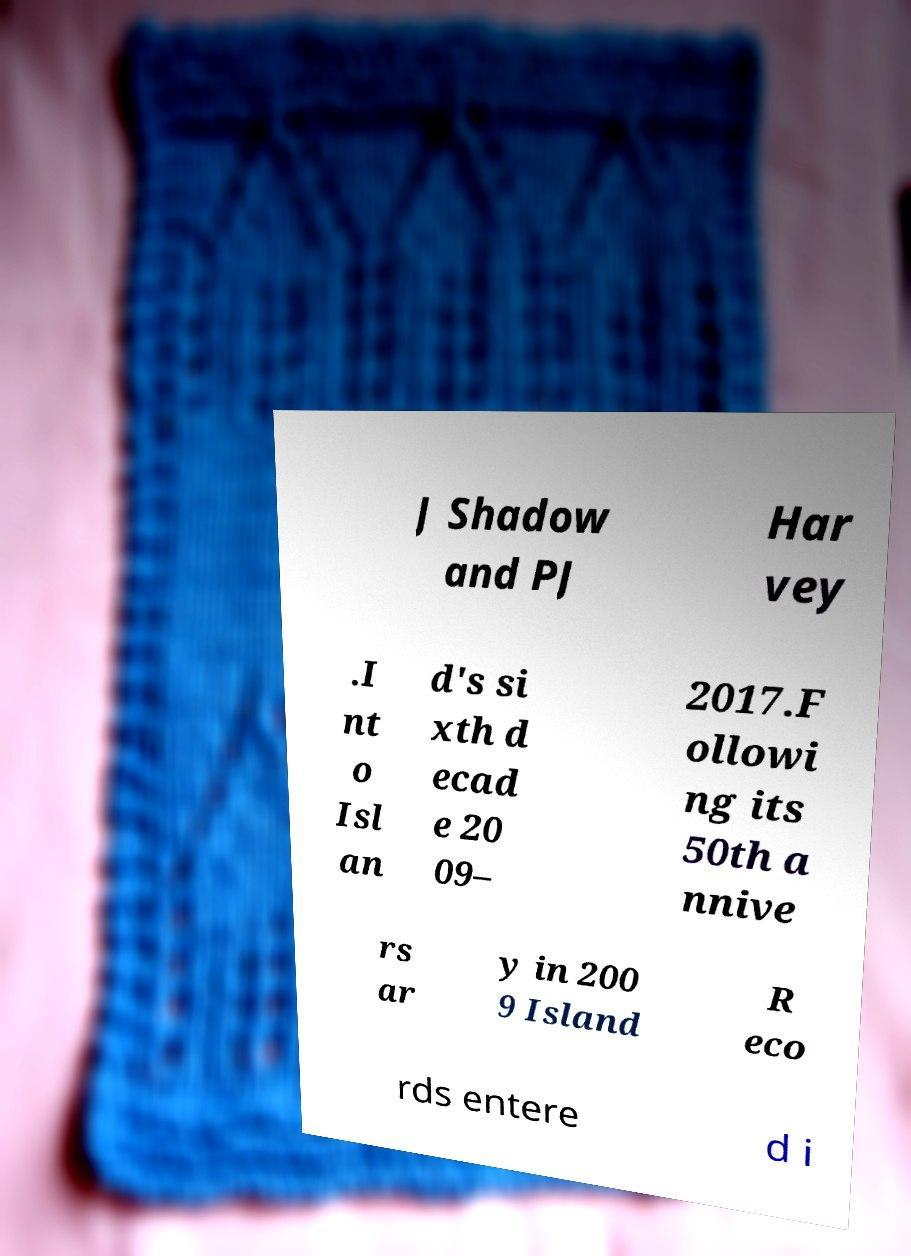There's text embedded in this image that I need extracted. Can you transcribe it verbatim? J Shadow and PJ Har vey .I nt o Isl an d's si xth d ecad e 20 09– 2017.F ollowi ng its 50th a nnive rs ar y in 200 9 Island R eco rds entere d i 